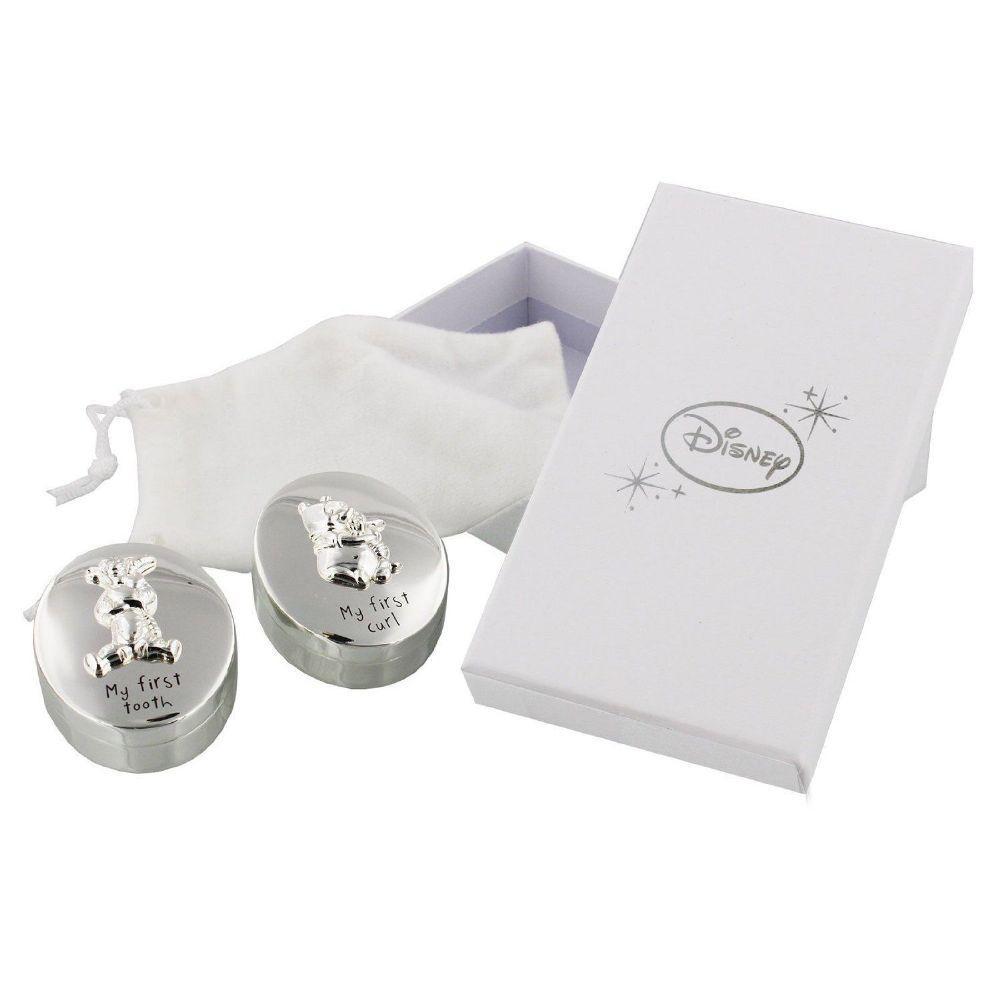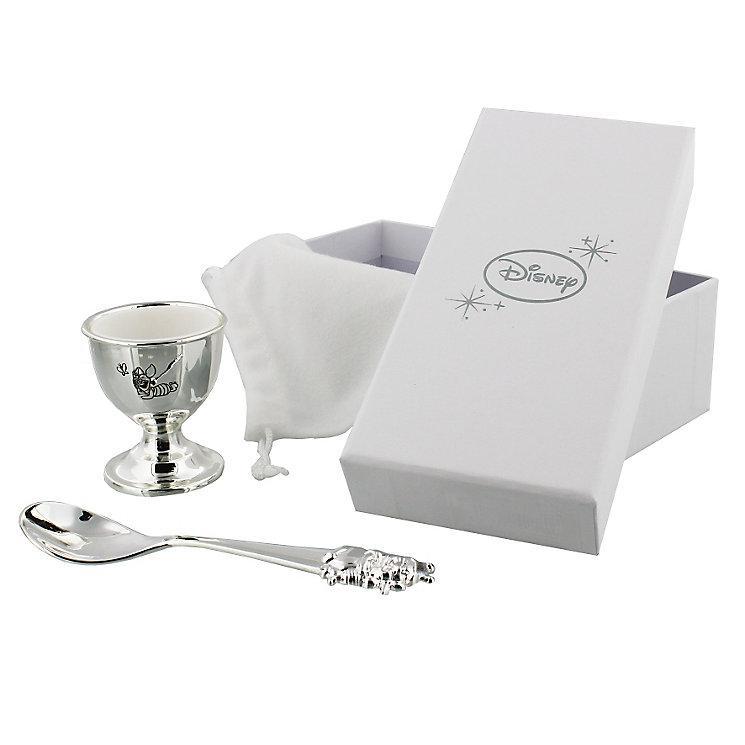The first image is the image on the left, the second image is the image on the right. Evaluate the accuracy of this statement regarding the images: "The left image depicts exactly one spoon next to one container.". Is it true? Answer yes or no. No. 